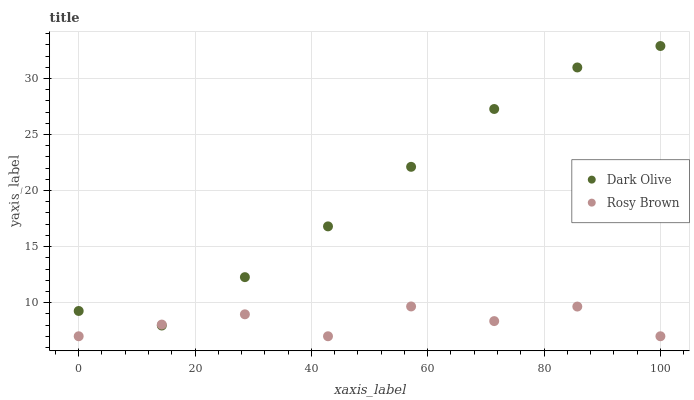Does Rosy Brown have the minimum area under the curve?
Answer yes or no. Yes. Does Dark Olive have the maximum area under the curve?
Answer yes or no. Yes. Does Dark Olive have the minimum area under the curve?
Answer yes or no. No. Is Dark Olive the smoothest?
Answer yes or no. Yes. Is Rosy Brown the roughest?
Answer yes or no. Yes. Is Dark Olive the roughest?
Answer yes or no. No. Does Rosy Brown have the lowest value?
Answer yes or no. Yes. Does Dark Olive have the lowest value?
Answer yes or no. No. Does Dark Olive have the highest value?
Answer yes or no. Yes. Does Rosy Brown intersect Dark Olive?
Answer yes or no. Yes. Is Rosy Brown less than Dark Olive?
Answer yes or no. No. Is Rosy Brown greater than Dark Olive?
Answer yes or no. No. 